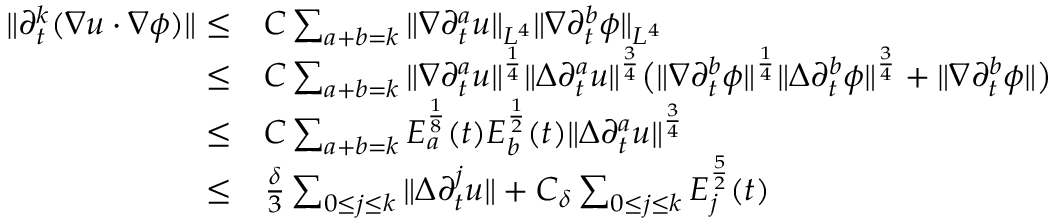<formula> <loc_0><loc_0><loc_500><loc_500>\begin{array} { r l } { \| \partial _ { t } ^ { k } ( \nabla u \cdot \nabla \phi ) \| \leq } & { C \sum _ { a + b = k } \| \nabla \partial _ { t } ^ { a } u \| _ { L ^ { 4 } } \| \nabla \partial _ { t } ^ { b } \phi \| _ { L ^ { 4 } } } \\ { \leq } & { C \sum _ { a + b = k } \| \nabla \partial _ { t } ^ { a } u \| ^ { \frac { 1 } { 4 } } \| \Delta \partial _ { t } ^ { a } u \| ^ { \frac { 3 } { 4 } } \left ( \| \nabla \partial _ { t } ^ { b } \phi \| ^ { \frac { 1 } { 4 } } \| \Delta \partial _ { t } ^ { b } \phi \| ^ { \frac { 3 } { 4 } } + \| \nabla \partial _ { t } ^ { b } \phi \| \right ) } \\ { \leq } & { C \sum _ { a + b = k } E _ { a } ^ { \frac { 1 } { 8 } } ( t ) E _ { b } ^ { \frac { 1 } { 2 } } ( t ) \| \Delta \partial _ { t } ^ { a } u \| ^ { \frac { 3 } { 4 } } } \\ { \leq } & { \frac { \delta } { 3 } \sum _ { 0 \leq j \leq k } \| \Delta \partial _ { t } ^ { j } u \| + C _ { \delta } \sum _ { 0 \leq j \leq k } E _ { j } ^ { \frac { 5 } { 2 } } ( t ) } \end{array}</formula> 